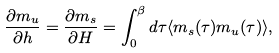<formula> <loc_0><loc_0><loc_500><loc_500>\frac { \partial m _ { u } } { \partial h } = \frac { \partial m _ { s } } { \partial H } = \int _ { 0 } ^ { \beta } d \tau \langle m _ { s } ( \tau ) m _ { u } ( \tau ) \rangle ,</formula> 